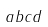<formula> <loc_0><loc_0><loc_500><loc_500>a b c d</formula> 